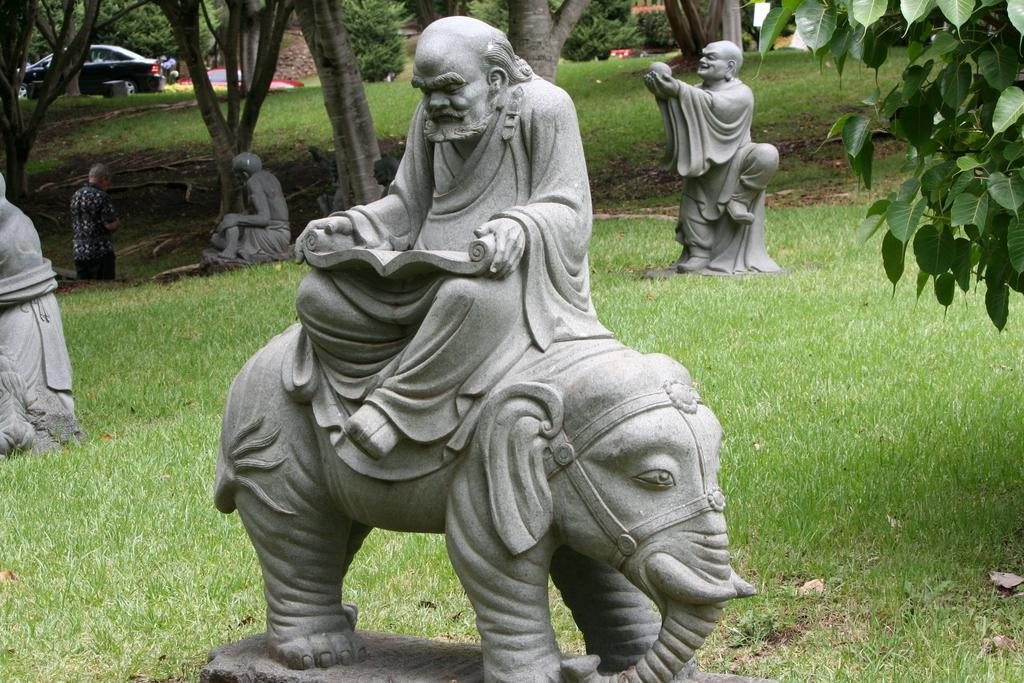What type of objects are depicted as statues in the image? There are statues of people and an animal in the image. What can be seen in the background of the image? There are vehicles and trees in the background of the image. Is there a person present in the image? Yes, there is a person standing in the image. What type of furniture is being used by the sun in the image? There is no furniture or sun present in the image. How many balls are visible in the image? There are no balls visible in the image. 